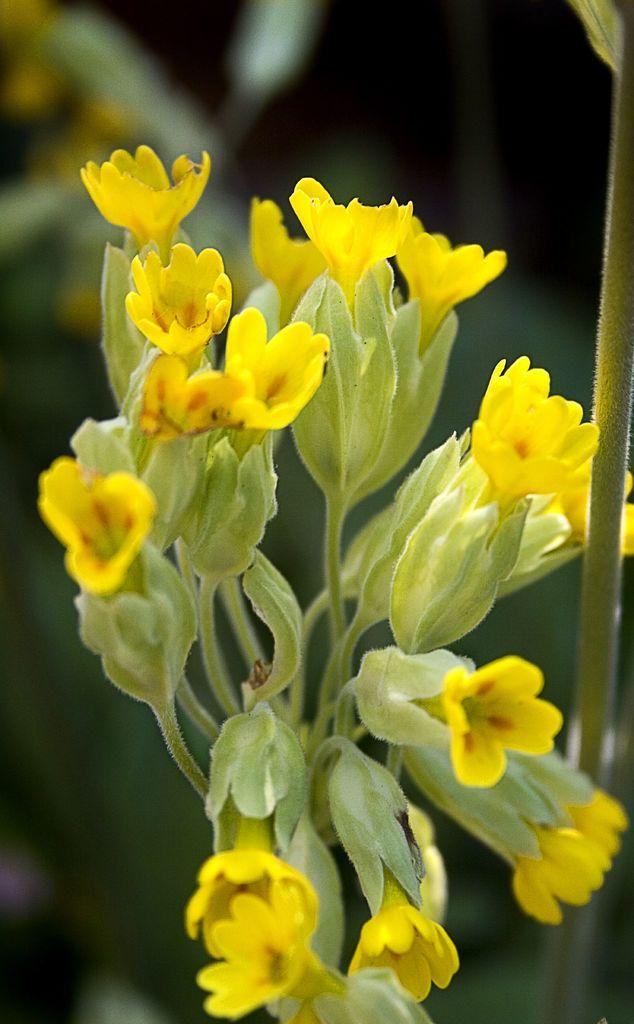What type of plants can be seen in the image? There are flowers in the image. What part of the flowers is visible in the image? There are stems in the image. Can you describe the background of the image? The background of the image is blurred. What type of thought is expressed by the sofa in the image? There is no sofa present in the image, and therefore no thoughts can be attributed to it. 